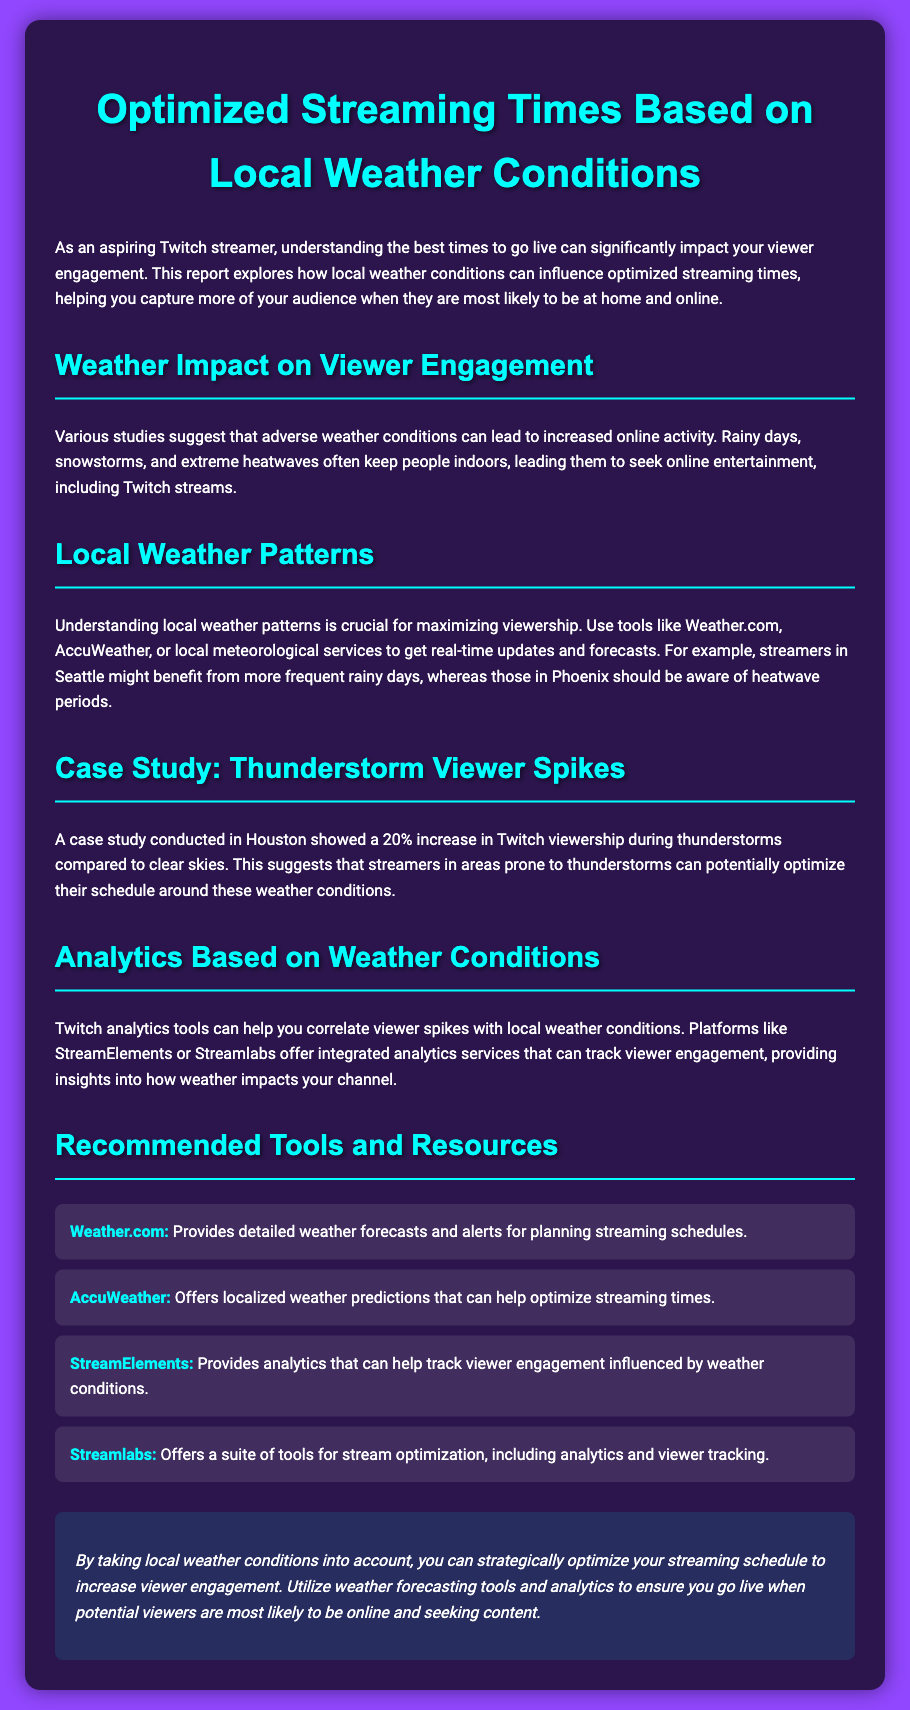What is the title of the document? The title of the document is prominently displayed at the top and indicates its main theme.
Answer: Optimized Streaming Times Based on Local Weather Conditions What weather conditions lead to increased online activity? The document mentions specific adverse weather conditions that correlate with higher viewer engagement.
Answer: Rainy days, snowstorms, extreme heatwaves What city was referenced in the case study? The case study discusses viewer spikes during specific weather conditions in a particular city.
Answer: Houston By how much did viewer engagement increase during thunderstorms? The document provides a specific percentage increase in Twitch viewership during thunderstorms compared to clear skies.
Answer: 20% Which tool provides detailed weather forecasts? The document lists various tools and their functionalities, including who provides forecasts.
Answer: Weather.com What is one of the recommended tools for tracking viewer engagement? The document mentions the names of platforms that offer analytics services for streamers.
Answer: StreamElements How can local weather patterns impact streaming schedules? The document explains the importance of understanding local weather and its influence on optimal streaming times.
Answer: Maximize viewership What color is used for the main headings? The document describes the styling elements, which include specific colors for text.
Answer: Cyan What is the background color of the document? The document specifies the aesthetic choices including background color.
Answer: Purple 